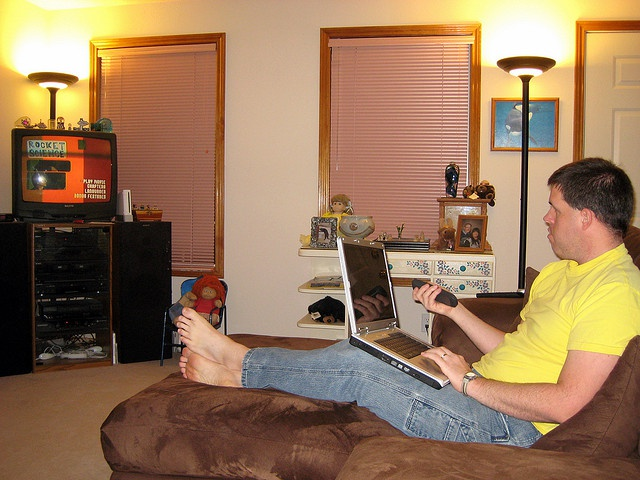Describe the objects in this image and their specific colors. I can see people in gold, khaki, tan, and darkgray tones, couch in gold, maroon, and brown tones, tv in gold, black, maroon, and red tones, laptop in gold, black, maroon, and gray tones, and chair in gold, black, maroon, and gray tones in this image. 